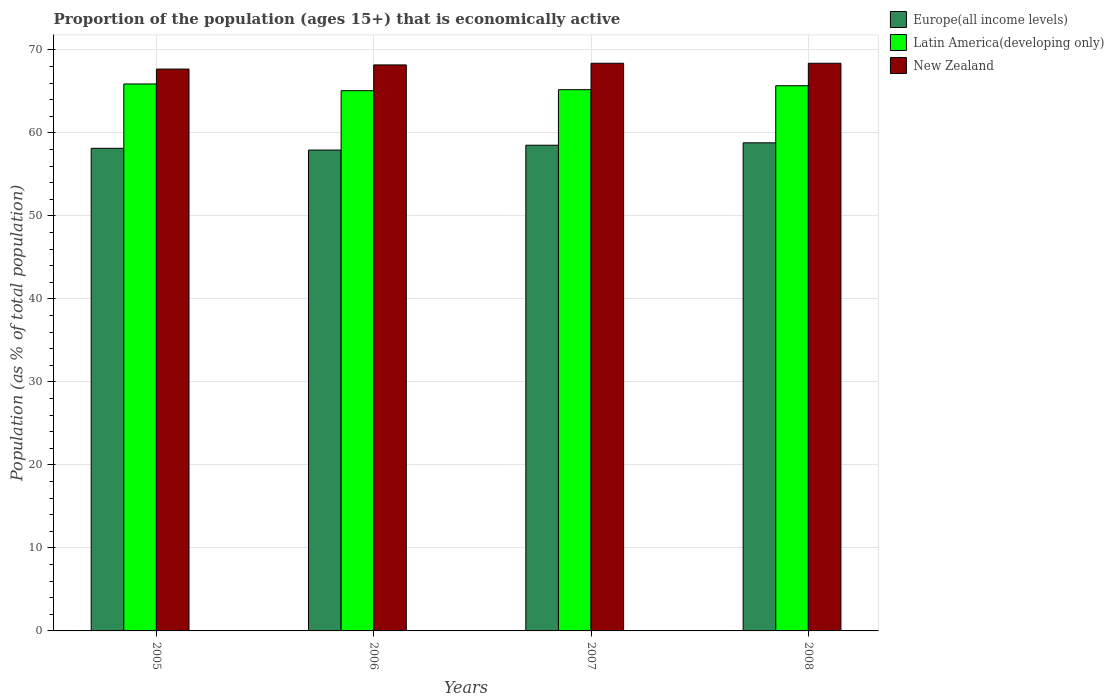How many groups of bars are there?
Keep it short and to the point. 4. Are the number of bars per tick equal to the number of legend labels?
Offer a very short reply. Yes. Are the number of bars on each tick of the X-axis equal?
Your response must be concise. Yes. How many bars are there on the 4th tick from the right?
Your answer should be very brief. 3. In how many cases, is the number of bars for a given year not equal to the number of legend labels?
Your answer should be compact. 0. What is the proportion of the population that is economically active in Europe(all income levels) in 2008?
Offer a terse response. 58.81. Across all years, what is the maximum proportion of the population that is economically active in New Zealand?
Provide a short and direct response. 68.4. Across all years, what is the minimum proportion of the population that is economically active in New Zealand?
Provide a short and direct response. 67.7. In which year was the proportion of the population that is economically active in New Zealand minimum?
Ensure brevity in your answer.  2005. What is the total proportion of the population that is economically active in Latin America(developing only) in the graph?
Keep it short and to the point. 261.91. What is the difference between the proportion of the population that is economically active in New Zealand in 2006 and that in 2007?
Ensure brevity in your answer.  -0.2. What is the difference between the proportion of the population that is economically active in New Zealand in 2008 and the proportion of the population that is economically active in Europe(all income levels) in 2005?
Your answer should be compact. 10.25. What is the average proportion of the population that is economically active in Latin America(developing only) per year?
Ensure brevity in your answer.  65.48. In the year 2008, what is the difference between the proportion of the population that is economically active in Europe(all income levels) and proportion of the population that is economically active in New Zealand?
Your answer should be very brief. -9.59. What is the ratio of the proportion of the population that is economically active in Europe(all income levels) in 2006 to that in 2007?
Make the answer very short. 0.99. What is the difference between the highest and the second highest proportion of the population that is economically active in New Zealand?
Offer a very short reply. 0. What is the difference between the highest and the lowest proportion of the population that is economically active in New Zealand?
Your answer should be very brief. 0.7. In how many years, is the proportion of the population that is economically active in New Zealand greater than the average proportion of the population that is economically active in New Zealand taken over all years?
Your answer should be very brief. 3. Is the sum of the proportion of the population that is economically active in Latin America(developing only) in 2007 and 2008 greater than the maximum proportion of the population that is economically active in New Zealand across all years?
Your answer should be compact. Yes. What does the 3rd bar from the left in 2007 represents?
Keep it short and to the point. New Zealand. What does the 2nd bar from the right in 2005 represents?
Offer a very short reply. Latin America(developing only). Is it the case that in every year, the sum of the proportion of the population that is economically active in New Zealand and proportion of the population that is economically active in Europe(all income levels) is greater than the proportion of the population that is economically active in Latin America(developing only)?
Keep it short and to the point. Yes. How many years are there in the graph?
Give a very brief answer. 4. What is the difference between two consecutive major ticks on the Y-axis?
Your answer should be compact. 10. Does the graph contain any zero values?
Your answer should be very brief. No. Does the graph contain grids?
Your answer should be very brief. Yes. Where does the legend appear in the graph?
Make the answer very short. Top right. How many legend labels are there?
Provide a short and direct response. 3. What is the title of the graph?
Offer a terse response. Proportion of the population (ages 15+) that is economically active. What is the label or title of the Y-axis?
Your answer should be very brief. Population (as % of total population). What is the Population (as % of total population) in Europe(all income levels) in 2005?
Offer a very short reply. 58.15. What is the Population (as % of total population) of Latin America(developing only) in 2005?
Your answer should be very brief. 65.9. What is the Population (as % of total population) of New Zealand in 2005?
Keep it short and to the point. 67.7. What is the Population (as % of total population) in Europe(all income levels) in 2006?
Give a very brief answer. 57.94. What is the Population (as % of total population) in Latin America(developing only) in 2006?
Offer a very short reply. 65.1. What is the Population (as % of total population) of New Zealand in 2006?
Offer a very short reply. 68.2. What is the Population (as % of total population) in Europe(all income levels) in 2007?
Offer a very short reply. 58.52. What is the Population (as % of total population) in Latin America(developing only) in 2007?
Ensure brevity in your answer.  65.21. What is the Population (as % of total population) in New Zealand in 2007?
Offer a very short reply. 68.4. What is the Population (as % of total population) in Europe(all income levels) in 2008?
Offer a very short reply. 58.81. What is the Population (as % of total population) of Latin America(developing only) in 2008?
Your answer should be compact. 65.69. What is the Population (as % of total population) in New Zealand in 2008?
Give a very brief answer. 68.4. Across all years, what is the maximum Population (as % of total population) in Europe(all income levels)?
Make the answer very short. 58.81. Across all years, what is the maximum Population (as % of total population) of Latin America(developing only)?
Give a very brief answer. 65.9. Across all years, what is the maximum Population (as % of total population) of New Zealand?
Your answer should be compact. 68.4. Across all years, what is the minimum Population (as % of total population) of Europe(all income levels)?
Offer a very short reply. 57.94. Across all years, what is the minimum Population (as % of total population) in Latin America(developing only)?
Make the answer very short. 65.1. Across all years, what is the minimum Population (as % of total population) in New Zealand?
Provide a succinct answer. 67.7. What is the total Population (as % of total population) of Europe(all income levels) in the graph?
Your answer should be very brief. 233.43. What is the total Population (as % of total population) in Latin America(developing only) in the graph?
Your answer should be very brief. 261.91. What is the total Population (as % of total population) in New Zealand in the graph?
Provide a short and direct response. 272.7. What is the difference between the Population (as % of total population) in Europe(all income levels) in 2005 and that in 2006?
Provide a short and direct response. 0.21. What is the difference between the Population (as % of total population) in Latin America(developing only) in 2005 and that in 2006?
Provide a short and direct response. 0.81. What is the difference between the Population (as % of total population) in New Zealand in 2005 and that in 2006?
Make the answer very short. -0.5. What is the difference between the Population (as % of total population) in Europe(all income levels) in 2005 and that in 2007?
Make the answer very short. -0.37. What is the difference between the Population (as % of total population) of Latin America(developing only) in 2005 and that in 2007?
Ensure brevity in your answer.  0.69. What is the difference between the Population (as % of total population) in New Zealand in 2005 and that in 2007?
Offer a very short reply. -0.7. What is the difference between the Population (as % of total population) of Europe(all income levels) in 2005 and that in 2008?
Your answer should be very brief. -0.66. What is the difference between the Population (as % of total population) in Latin America(developing only) in 2005 and that in 2008?
Keep it short and to the point. 0.21. What is the difference between the Population (as % of total population) in Europe(all income levels) in 2006 and that in 2007?
Keep it short and to the point. -0.58. What is the difference between the Population (as % of total population) of Latin America(developing only) in 2006 and that in 2007?
Ensure brevity in your answer.  -0.12. What is the difference between the Population (as % of total population) of Europe(all income levels) in 2006 and that in 2008?
Your answer should be very brief. -0.87. What is the difference between the Population (as % of total population) of Latin America(developing only) in 2006 and that in 2008?
Provide a succinct answer. -0.6. What is the difference between the Population (as % of total population) of New Zealand in 2006 and that in 2008?
Your answer should be very brief. -0.2. What is the difference between the Population (as % of total population) in Europe(all income levels) in 2007 and that in 2008?
Make the answer very short. -0.29. What is the difference between the Population (as % of total population) of Latin America(developing only) in 2007 and that in 2008?
Give a very brief answer. -0.48. What is the difference between the Population (as % of total population) in Europe(all income levels) in 2005 and the Population (as % of total population) in Latin America(developing only) in 2006?
Offer a very short reply. -6.94. What is the difference between the Population (as % of total population) in Europe(all income levels) in 2005 and the Population (as % of total population) in New Zealand in 2006?
Your answer should be compact. -10.05. What is the difference between the Population (as % of total population) of Latin America(developing only) in 2005 and the Population (as % of total population) of New Zealand in 2006?
Your response must be concise. -2.3. What is the difference between the Population (as % of total population) of Europe(all income levels) in 2005 and the Population (as % of total population) of Latin America(developing only) in 2007?
Your response must be concise. -7.06. What is the difference between the Population (as % of total population) in Europe(all income levels) in 2005 and the Population (as % of total population) in New Zealand in 2007?
Give a very brief answer. -10.25. What is the difference between the Population (as % of total population) in Latin America(developing only) in 2005 and the Population (as % of total population) in New Zealand in 2007?
Ensure brevity in your answer.  -2.5. What is the difference between the Population (as % of total population) of Europe(all income levels) in 2005 and the Population (as % of total population) of Latin America(developing only) in 2008?
Ensure brevity in your answer.  -7.54. What is the difference between the Population (as % of total population) of Europe(all income levels) in 2005 and the Population (as % of total population) of New Zealand in 2008?
Ensure brevity in your answer.  -10.25. What is the difference between the Population (as % of total population) of Latin America(developing only) in 2005 and the Population (as % of total population) of New Zealand in 2008?
Keep it short and to the point. -2.5. What is the difference between the Population (as % of total population) of Europe(all income levels) in 2006 and the Population (as % of total population) of Latin America(developing only) in 2007?
Provide a succinct answer. -7.27. What is the difference between the Population (as % of total population) of Europe(all income levels) in 2006 and the Population (as % of total population) of New Zealand in 2007?
Your answer should be compact. -10.46. What is the difference between the Population (as % of total population) of Latin America(developing only) in 2006 and the Population (as % of total population) of New Zealand in 2007?
Make the answer very short. -3.3. What is the difference between the Population (as % of total population) of Europe(all income levels) in 2006 and the Population (as % of total population) of Latin America(developing only) in 2008?
Your response must be concise. -7.75. What is the difference between the Population (as % of total population) in Europe(all income levels) in 2006 and the Population (as % of total population) in New Zealand in 2008?
Provide a succinct answer. -10.46. What is the difference between the Population (as % of total population) in Latin America(developing only) in 2006 and the Population (as % of total population) in New Zealand in 2008?
Your response must be concise. -3.3. What is the difference between the Population (as % of total population) of Europe(all income levels) in 2007 and the Population (as % of total population) of Latin America(developing only) in 2008?
Offer a very short reply. -7.17. What is the difference between the Population (as % of total population) in Europe(all income levels) in 2007 and the Population (as % of total population) in New Zealand in 2008?
Your answer should be very brief. -9.88. What is the difference between the Population (as % of total population) of Latin America(developing only) in 2007 and the Population (as % of total population) of New Zealand in 2008?
Your answer should be compact. -3.19. What is the average Population (as % of total population) of Europe(all income levels) per year?
Your answer should be compact. 58.36. What is the average Population (as % of total population) in Latin America(developing only) per year?
Offer a terse response. 65.48. What is the average Population (as % of total population) of New Zealand per year?
Offer a terse response. 68.17. In the year 2005, what is the difference between the Population (as % of total population) of Europe(all income levels) and Population (as % of total population) of Latin America(developing only)?
Your response must be concise. -7.75. In the year 2005, what is the difference between the Population (as % of total population) in Europe(all income levels) and Population (as % of total population) in New Zealand?
Offer a very short reply. -9.55. In the year 2005, what is the difference between the Population (as % of total population) in Latin America(developing only) and Population (as % of total population) in New Zealand?
Your answer should be compact. -1.8. In the year 2006, what is the difference between the Population (as % of total population) in Europe(all income levels) and Population (as % of total population) in Latin America(developing only)?
Your answer should be compact. -7.15. In the year 2006, what is the difference between the Population (as % of total population) in Europe(all income levels) and Population (as % of total population) in New Zealand?
Make the answer very short. -10.26. In the year 2006, what is the difference between the Population (as % of total population) in Latin America(developing only) and Population (as % of total population) in New Zealand?
Make the answer very short. -3.1. In the year 2007, what is the difference between the Population (as % of total population) in Europe(all income levels) and Population (as % of total population) in Latin America(developing only)?
Offer a terse response. -6.69. In the year 2007, what is the difference between the Population (as % of total population) of Europe(all income levels) and Population (as % of total population) of New Zealand?
Offer a very short reply. -9.88. In the year 2007, what is the difference between the Population (as % of total population) of Latin America(developing only) and Population (as % of total population) of New Zealand?
Your answer should be very brief. -3.19. In the year 2008, what is the difference between the Population (as % of total population) in Europe(all income levels) and Population (as % of total population) in Latin America(developing only)?
Keep it short and to the point. -6.88. In the year 2008, what is the difference between the Population (as % of total population) of Europe(all income levels) and Population (as % of total population) of New Zealand?
Offer a very short reply. -9.59. In the year 2008, what is the difference between the Population (as % of total population) of Latin America(developing only) and Population (as % of total population) of New Zealand?
Ensure brevity in your answer.  -2.71. What is the ratio of the Population (as % of total population) of Latin America(developing only) in 2005 to that in 2006?
Offer a very short reply. 1.01. What is the ratio of the Population (as % of total population) of Europe(all income levels) in 2005 to that in 2007?
Provide a succinct answer. 0.99. What is the ratio of the Population (as % of total population) of Latin America(developing only) in 2005 to that in 2007?
Ensure brevity in your answer.  1.01. What is the ratio of the Population (as % of total population) of Europe(all income levels) in 2005 to that in 2008?
Keep it short and to the point. 0.99. What is the ratio of the Population (as % of total population) in Europe(all income levels) in 2006 to that in 2007?
Keep it short and to the point. 0.99. What is the ratio of the Population (as % of total population) in Latin America(developing only) in 2006 to that in 2007?
Offer a terse response. 1. What is the ratio of the Population (as % of total population) in Europe(all income levels) in 2006 to that in 2008?
Make the answer very short. 0.99. What is the ratio of the Population (as % of total population) in Latin America(developing only) in 2006 to that in 2008?
Give a very brief answer. 0.99. What is the ratio of the Population (as % of total population) in New Zealand in 2006 to that in 2008?
Your answer should be compact. 1. What is the ratio of the Population (as % of total population) in Europe(all income levels) in 2007 to that in 2008?
Make the answer very short. 1. What is the difference between the highest and the second highest Population (as % of total population) in Europe(all income levels)?
Offer a very short reply. 0.29. What is the difference between the highest and the second highest Population (as % of total population) of Latin America(developing only)?
Give a very brief answer. 0.21. What is the difference between the highest and the lowest Population (as % of total population) of Europe(all income levels)?
Make the answer very short. 0.87. What is the difference between the highest and the lowest Population (as % of total population) of Latin America(developing only)?
Offer a terse response. 0.81. What is the difference between the highest and the lowest Population (as % of total population) in New Zealand?
Provide a succinct answer. 0.7. 